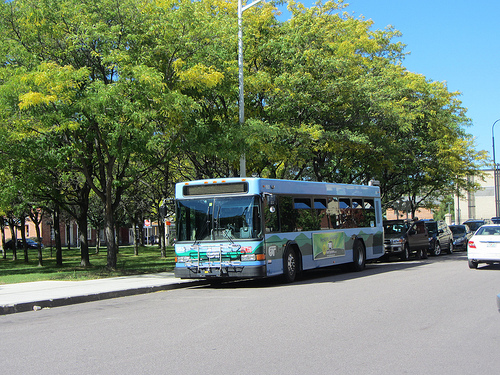Describe a scenario where the bus plays an essential role. Imagine a bustling city morning where children of all ages and backgrounds rush to the bus to get to school. The bus, with its punctual presence in the neighborhood, becomes a cornerstone of daily life. Parents wave their children goodbye, knowing they are in safe hands, while the bus driver greets the kids with a warm smile, ready to start their journey toward knowledge and growth. 